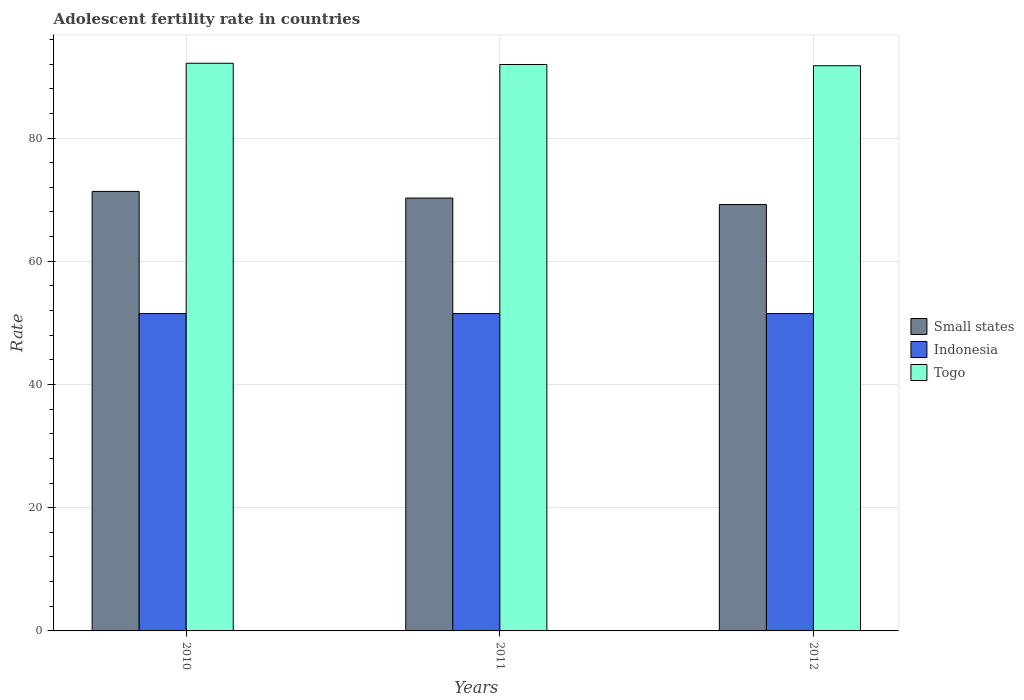Are the number of bars per tick equal to the number of legend labels?
Your response must be concise. Yes. What is the label of the 1st group of bars from the left?
Provide a succinct answer. 2010. What is the adolescent fertility rate in Indonesia in 2012?
Your answer should be very brief. 51.51. Across all years, what is the maximum adolescent fertility rate in Togo?
Give a very brief answer. 92.14. Across all years, what is the minimum adolescent fertility rate in Togo?
Give a very brief answer. 91.74. In which year was the adolescent fertility rate in Togo minimum?
Offer a very short reply. 2012. What is the total adolescent fertility rate in Indonesia in the graph?
Ensure brevity in your answer.  154.52. What is the difference between the adolescent fertility rate in Indonesia in 2011 and that in 2012?
Offer a terse response. 0. What is the difference between the adolescent fertility rate in Togo in 2011 and the adolescent fertility rate in Indonesia in 2010?
Your answer should be compact. 40.43. What is the average adolescent fertility rate in Small states per year?
Provide a short and direct response. 70.27. In the year 2011, what is the difference between the adolescent fertility rate in Small states and adolescent fertility rate in Indonesia?
Offer a terse response. 18.76. What is the difference between the highest and the second highest adolescent fertility rate in Small states?
Provide a succinct answer. 1.08. What is the difference between the highest and the lowest adolescent fertility rate in Small states?
Offer a terse response. 2.13. In how many years, is the adolescent fertility rate in Togo greater than the average adolescent fertility rate in Togo taken over all years?
Make the answer very short. 1. Is the sum of the adolescent fertility rate in Indonesia in 2010 and 2012 greater than the maximum adolescent fertility rate in Small states across all years?
Provide a short and direct response. Yes. What does the 3rd bar from the left in 2012 represents?
Make the answer very short. Togo. What does the 1st bar from the right in 2010 represents?
Your response must be concise. Togo. Is it the case that in every year, the sum of the adolescent fertility rate in Togo and adolescent fertility rate in Indonesia is greater than the adolescent fertility rate in Small states?
Ensure brevity in your answer.  Yes. Are all the bars in the graph horizontal?
Your answer should be very brief. No. How many years are there in the graph?
Provide a short and direct response. 3. What is the difference between two consecutive major ticks on the Y-axis?
Offer a very short reply. 20. Does the graph contain any zero values?
Ensure brevity in your answer.  No. Does the graph contain grids?
Ensure brevity in your answer.  Yes. Where does the legend appear in the graph?
Offer a very short reply. Center right. How many legend labels are there?
Your answer should be compact. 3. What is the title of the graph?
Provide a succinct answer. Adolescent fertility rate in countries. Does "Slovenia" appear as one of the legend labels in the graph?
Ensure brevity in your answer.  No. What is the label or title of the X-axis?
Give a very brief answer. Years. What is the label or title of the Y-axis?
Provide a succinct answer. Rate. What is the Rate of Small states in 2010?
Your answer should be compact. 71.34. What is the Rate of Indonesia in 2010?
Your answer should be compact. 51.51. What is the Rate in Togo in 2010?
Your response must be concise. 92.14. What is the Rate in Small states in 2011?
Your response must be concise. 70.26. What is the Rate of Indonesia in 2011?
Offer a terse response. 51.51. What is the Rate in Togo in 2011?
Offer a terse response. 91.94. What is the Rate of Small states in 2012?
Give a very brief answer. 69.21. What is the Rate of Indonesia in 2012?
Keep it short and to the point. 51.51. What is the Rate of Togo in 2012?
Make the answer very short. 91.74. Across all years, what is the maximum Rate of Small states?
Your answer should be very brief. 71.34. Across all years, what is the maximum Rate of Indonesia?
Your answer should be compact. 51.51. Across all years, what is the maximum Rate in Togo?
Your response must be concise. 92.14. Across all years, what is the minimum Rate of Small states?
Your response must be concise. 69.21. Across all years, what is the minimum Rate in Indonesia?
Offer a terse response. 51.51. Across all years, what is the minimum Rate in Togo?
Provide a succinct answer. 91.74. What is the total Rate in Small states in the graph?
Provide a short and direct response. 210.8. What is the total Rate of Indonesia in the graph?
Your answer should be very brief. 154.51. What is the total Rate in Togo in the graph?
Make the answer very short. 275.81. What is the difference between the Rate in Small states in 2010 and that in 2011?
Provide a succinct answer. 1.08. What is the difference between the Rate in Togo in 2010 and that in 2011?
Ensure brevity in your answer.  0.2. What is the difference between the Rate in Small states in 2010 and that in 2012?
Your response must be concise. 2.13. What is the difference between the Rate in Indonesia in 2010 and that in 2012?
Ensure brevity in your answer.  0. What is the difference between the Rate in Togo in 2010 and that in 2012?
Offer a very short reply. 0.4. What is the difference between the Rate in Small states in 2011 and that in 2012?
Provide a short and direct response. 1.05. What is the difference between the Rate of Indonesia in 2011 and that in 2012?
Offer a very short reply. 0. What is the difference between the Rate of Togo in 2011 and that in 2012?
Your answer should be very brief. 0.2. What is the difference between the Rate in Small states in 2010 and the Rate in Indonesia in 2011?
Your answer should be compact. 19.83. What is the difference between the Rate of Small states in 2010 and the Rate of Togo in 2011?
Provide a short and direct response. -20.6. What is the difference between the Rate in Indonesia in 2010 and the Rate in Togo in 2011?
Keep it short and to the point. -40.43. What is the difference between the Rate of Small states in 2010 and the Rate of Indonesia in 2012?
Give a very brief answer. 19.83. What is the difference between the Rate in Small states in 2010 and the Rate in Togo in 2012?
Keep it short and to the point. -20.4. What is the difference between the Rate in Indonesia in 2010 and the Rate in Togo in 2012?
Offer a very short reply. -40.23. What is the difference between the Rate of Small states in 2011 and the Rate of Indonesia in 2012?
Provide a succinct answer. 18.75. What is the difference between the Rate of Small states in 2011 and the Rate of Togo in 2012?
Make the answer very short. -21.48. What is the difference between the Rate of Indonesia in 2011 and the Rate of Togo in 2012?
Your answer should be very brief. -40.23. What is the average Rate in Small states per year?
Give a very brief answer. 70.27. What is the average Rate of Indonesia per year?
Make the answer very short. 51.51. What is the average Rate in Togo per year?
Make the answer very short. 91.94. In the year 2010, what is the difference between the Rate in Small states and Rate in Indonesia?
Offer a terse response. 19.83. In the year 2010, what is the difference between the Rate of Small states and Rate of Togo?
Provide a short and direct response. -20.8. In the year 2010, what is the difference between the Rate in Indonesia and Rate in Togo?
Provide a succinct answer. -40.63. In the year 2011, what is the difference between the Rate of Small states and Rate of Indonesia?
Your response must be concise. 18.75. In the year 2011, what is the difference between the Rate in Small states and Rate in Togo?
Offer a very short reply. -21.68. In the year 2011, what is the difference between the Rate of Indonesia and Rate of Togo?
Your answer should be compact. -40.43. In the year 2012, what is the difference between the Rate in Small states and Rate in Indonesia?
Offer a terse response. 17.7. In the year 2012, what is the difference between the Rate of Small states and Rate of Togo?
Give a very brief answer. -22.53. In the year 2012, what is the difference between the Rate of Indonesia and Rate of Togo?
Provide a succinct answer. -40.23. What is the ratio of the Rate in Small states in 2010 to that in 2011?
Provide a succinct answer. 1.02. What is the ratio of the Rate of Indonesia in 2010 to that in 2011?
Provide a short and direct response. 1. What is the ratio of the Rate in Small states in 2010 to that in 2012?
Make the answer very short. 1.03. What is the ratio of the Rate of Indonesia in 2010 to that in 2012?
Your answer should be compact. 1. What is the ratio of the Rate of Togo in 2010 to that in 2012?
Keep it short and to the point. 1. What is the ratio of the Rate of Small states in 2011 to that in 2012?
Your answer should be compact. 1.02. What is the ratio of the Rate in Togo in 2011 to that in 2012?
Provide a short and direct response. 1. What is the difference between the highest and the second highest Rate in Small states?
Provide a short and direct response. 1.08. What is the difference between the highest and the second highest Rate of Indonesia?
Keep it short and to the point. 0. What is the difference between the highest and the second highest Rate of Togo?
Your answer should be compact. 0.2. What is the difference between the highest and the lowest Rate of Small states?
Keep it short and to the point. 2.13. What is the difference between the highest and the lowest Rate of Togo?
Provide a succinct answer. 0.4. 